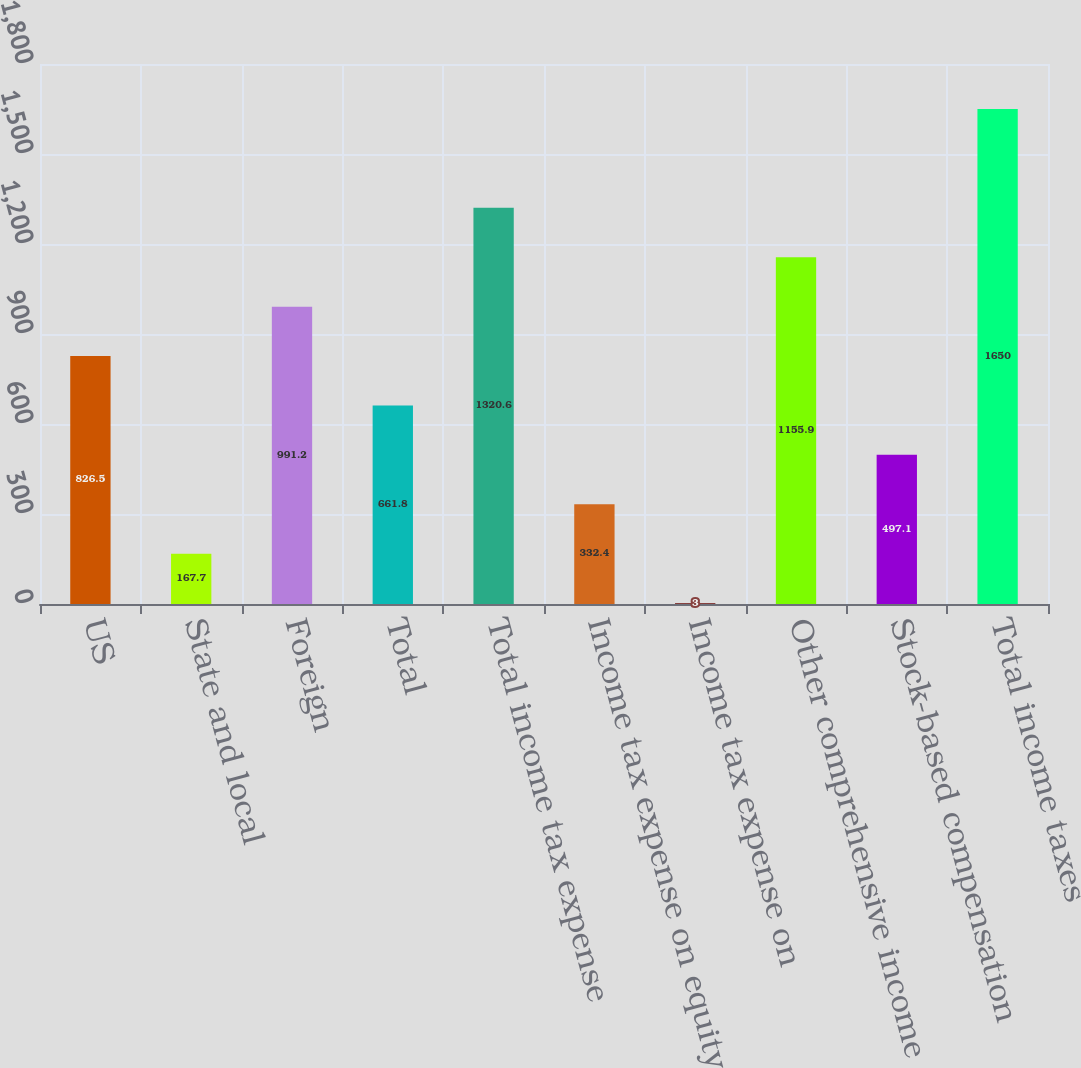<chart> <loc_0><loc_0><loc_500><loc_500><bar_chart><fcel>US<fcel>State and local<fcel>Foreign<fcel>Total<fcel>Total income tax expense<fcel>Income tax expense on equity<fcel>Income tax expense on<fcel>Other comprehensive income<fcel>Stock-based compensation<fcel>Total income taxes<nl><fcel>826.5<fcel>167.7<fcel>991.2<fcel>661.8<fcel>1320.6<fcel>332.4<fcel>3<fcel>1155.9<fcel>497.1<fcel>1650<nl></chart> 